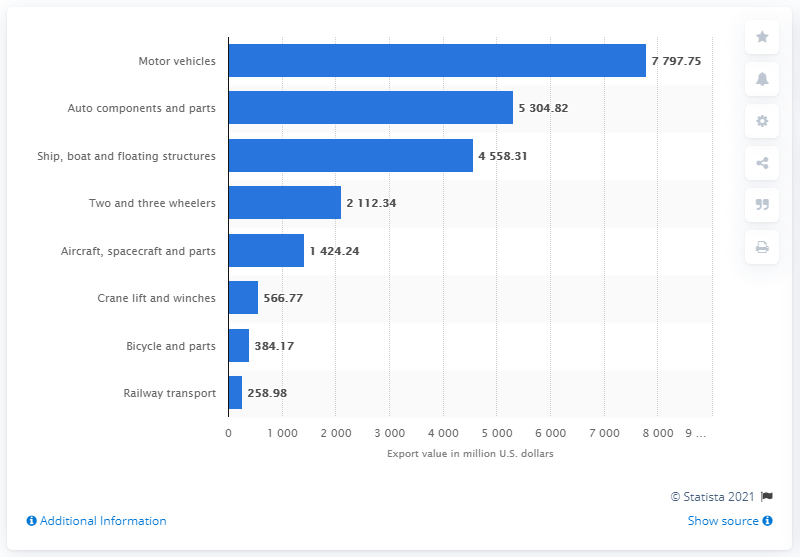Highlight a few significant elements in this photo. In the fiscal year 2020, the value of railway transport in Indian exports was 258.98. 